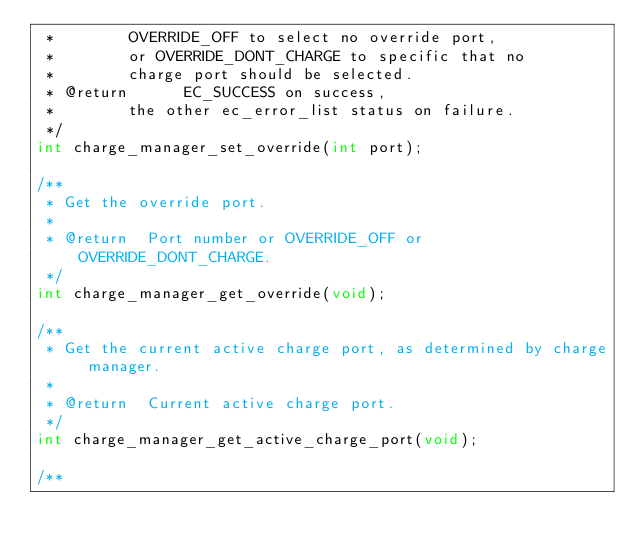<code> <loc_0><loc_0><loc_500><loc_500><_C_> *				OVERRIDE_OFF to select no override port,
 *				or OVERRIDE_DONT_CHARGE to specific that no
 *				charge port should be selected.
 * @return			EC_SUCCESS on success,
 *				the other ec_error_list status on failure.
 */
int charge_manager_set_override(int port);

/**
 * Get the override port.
 *
 * @return	Port number or OVERRIDE_OFF or OVERRIDE_DONT_CHARGE.
 */
int charge_manager_get_override(void);

/**
 * Get the current active charge port, as determined by charge manager.
 *
 * @return	Current active charge port.
 */
int charge_manager_get_active_charge_port(void);

/**</code> 